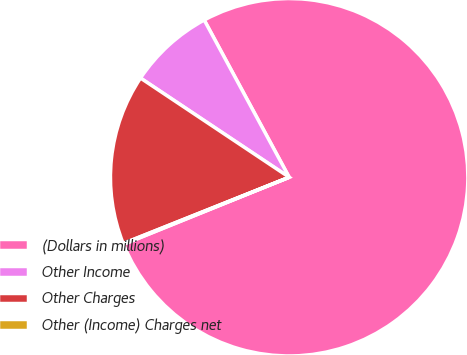<chart> <loc_0><loc_0><loc_500><loc_500><pie_chart><fcel>(Dollars in millions)<fcel>Other Income<fcel>Other Charges<fcel>Other (Income) Charges net<nl><fcel>76.76%<fcel>7.75%<fcel>15.41%<fcel>0.08%<nl></chart> 